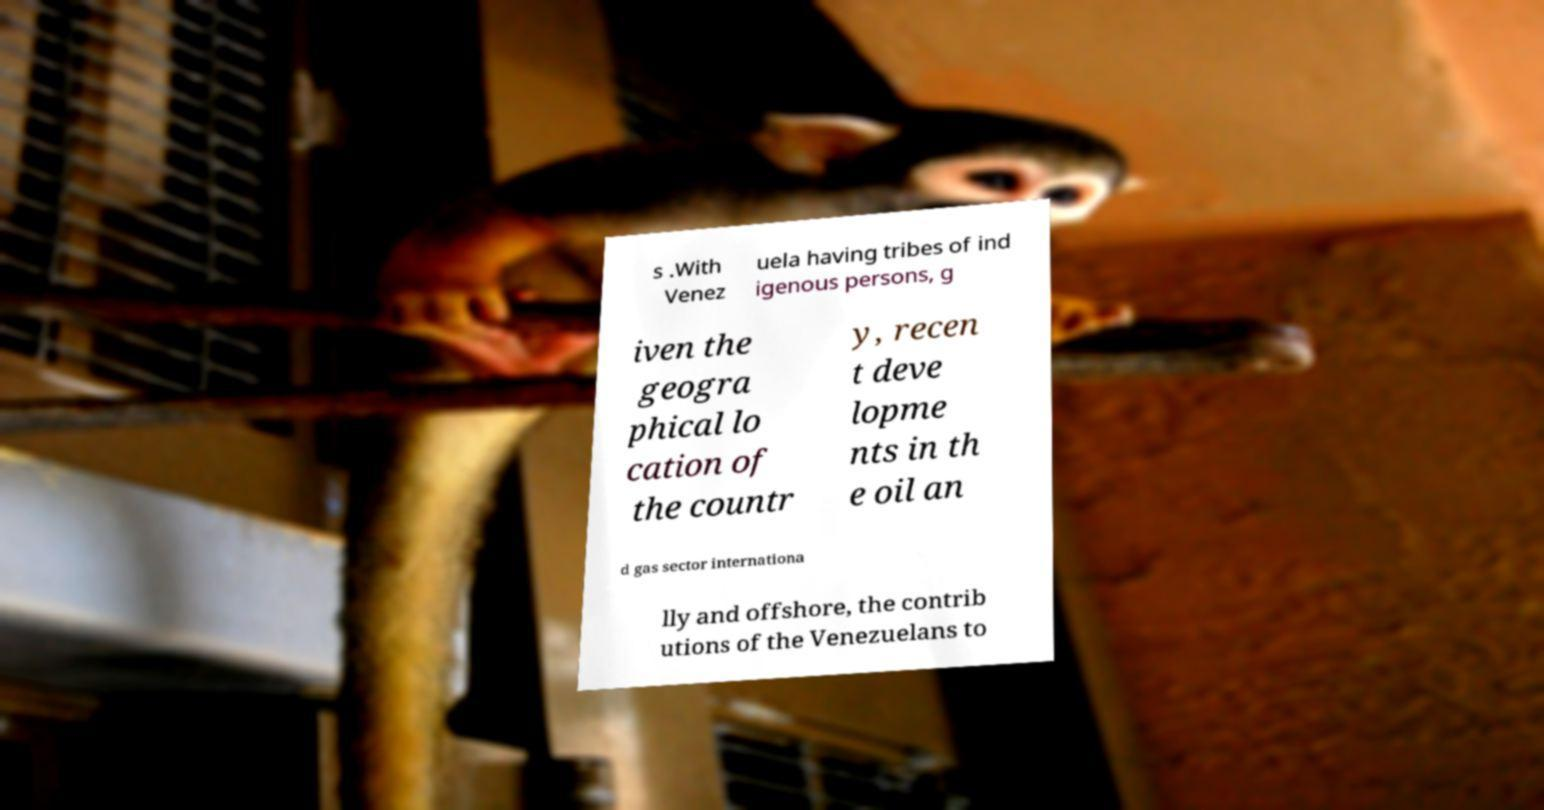Could you extract and type out the text from this image? s .With Venez uela having tribes of ind igenous persons, g iven the geogra phical lo cation of the countr y, recen t deve lopme nts in th e oil an d gas sector internationa lly and offshore, the contrib utions of the Venezuelans to 